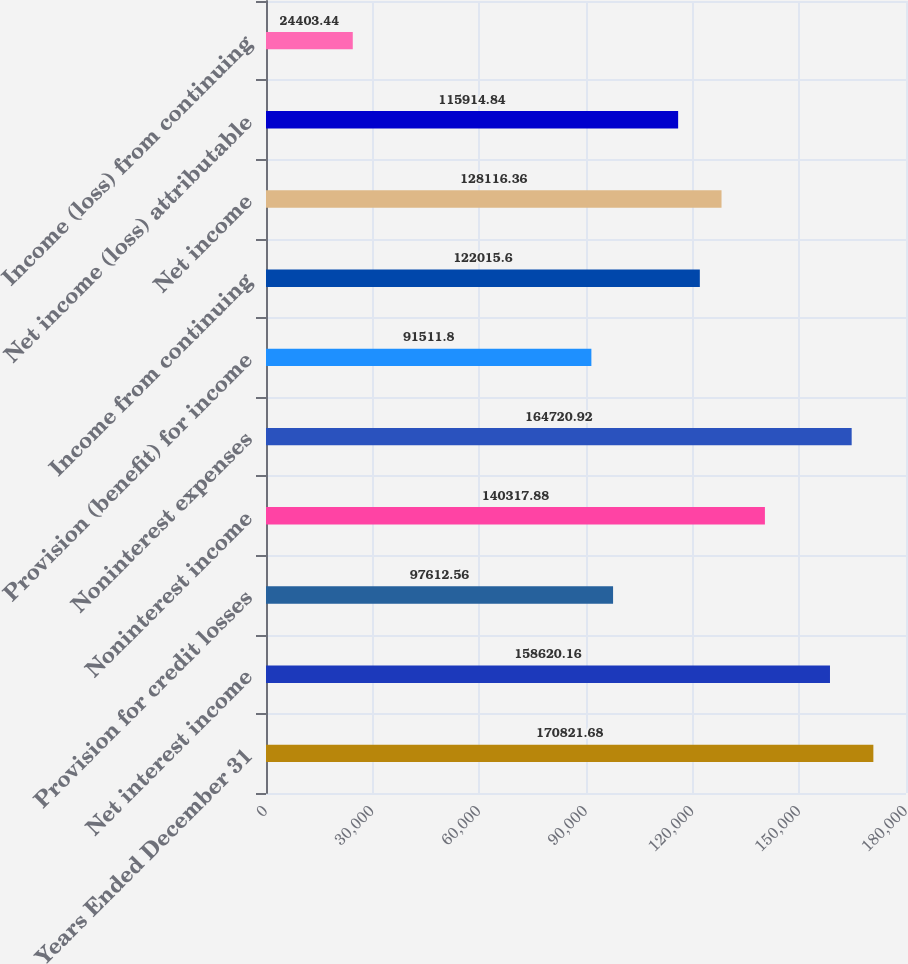Convert chart. <chart><loc_0><loc_0><loc_500><loc_500><bar_chart><fcel>Years Ended December 31<fcel>Net interest income<fcel>Provision for credit losses<fcel>Noninterest income<fcel>Noninterest expenses<fcel>Provision (benefit) for income<fcel>Income from continuing<fcel>Net income<fcel>Net income (loss) attributable<fcel>Income (loss) from continuing<nl><fcel>170822<fcel>158620<fcel>97612.6<fcel>140318<fcel>164721<fcel>91511.8<fcel>122016<fcel>128116<fcel>115915<fcel>24403.4<nl></chart> 